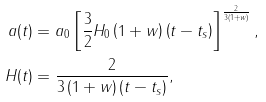<formula> <loc_0><loc_0><loc_500><loc_500>a ( t ) & = a _ { 0 } \left [ \frac { 3 } { 2 } H _ { 0 } \left ( 1 + w \right ) \left ( t - t _ { s } \right ) \right ] ^ { \frac { 2 } { 3 \left ( 1 + w \right ) } } , \\ H ( t ) & = \frac { 2 } { 3 \left ( 1 + w \right ) \left ( t - t _ { s } \right ) } ,</formula> 